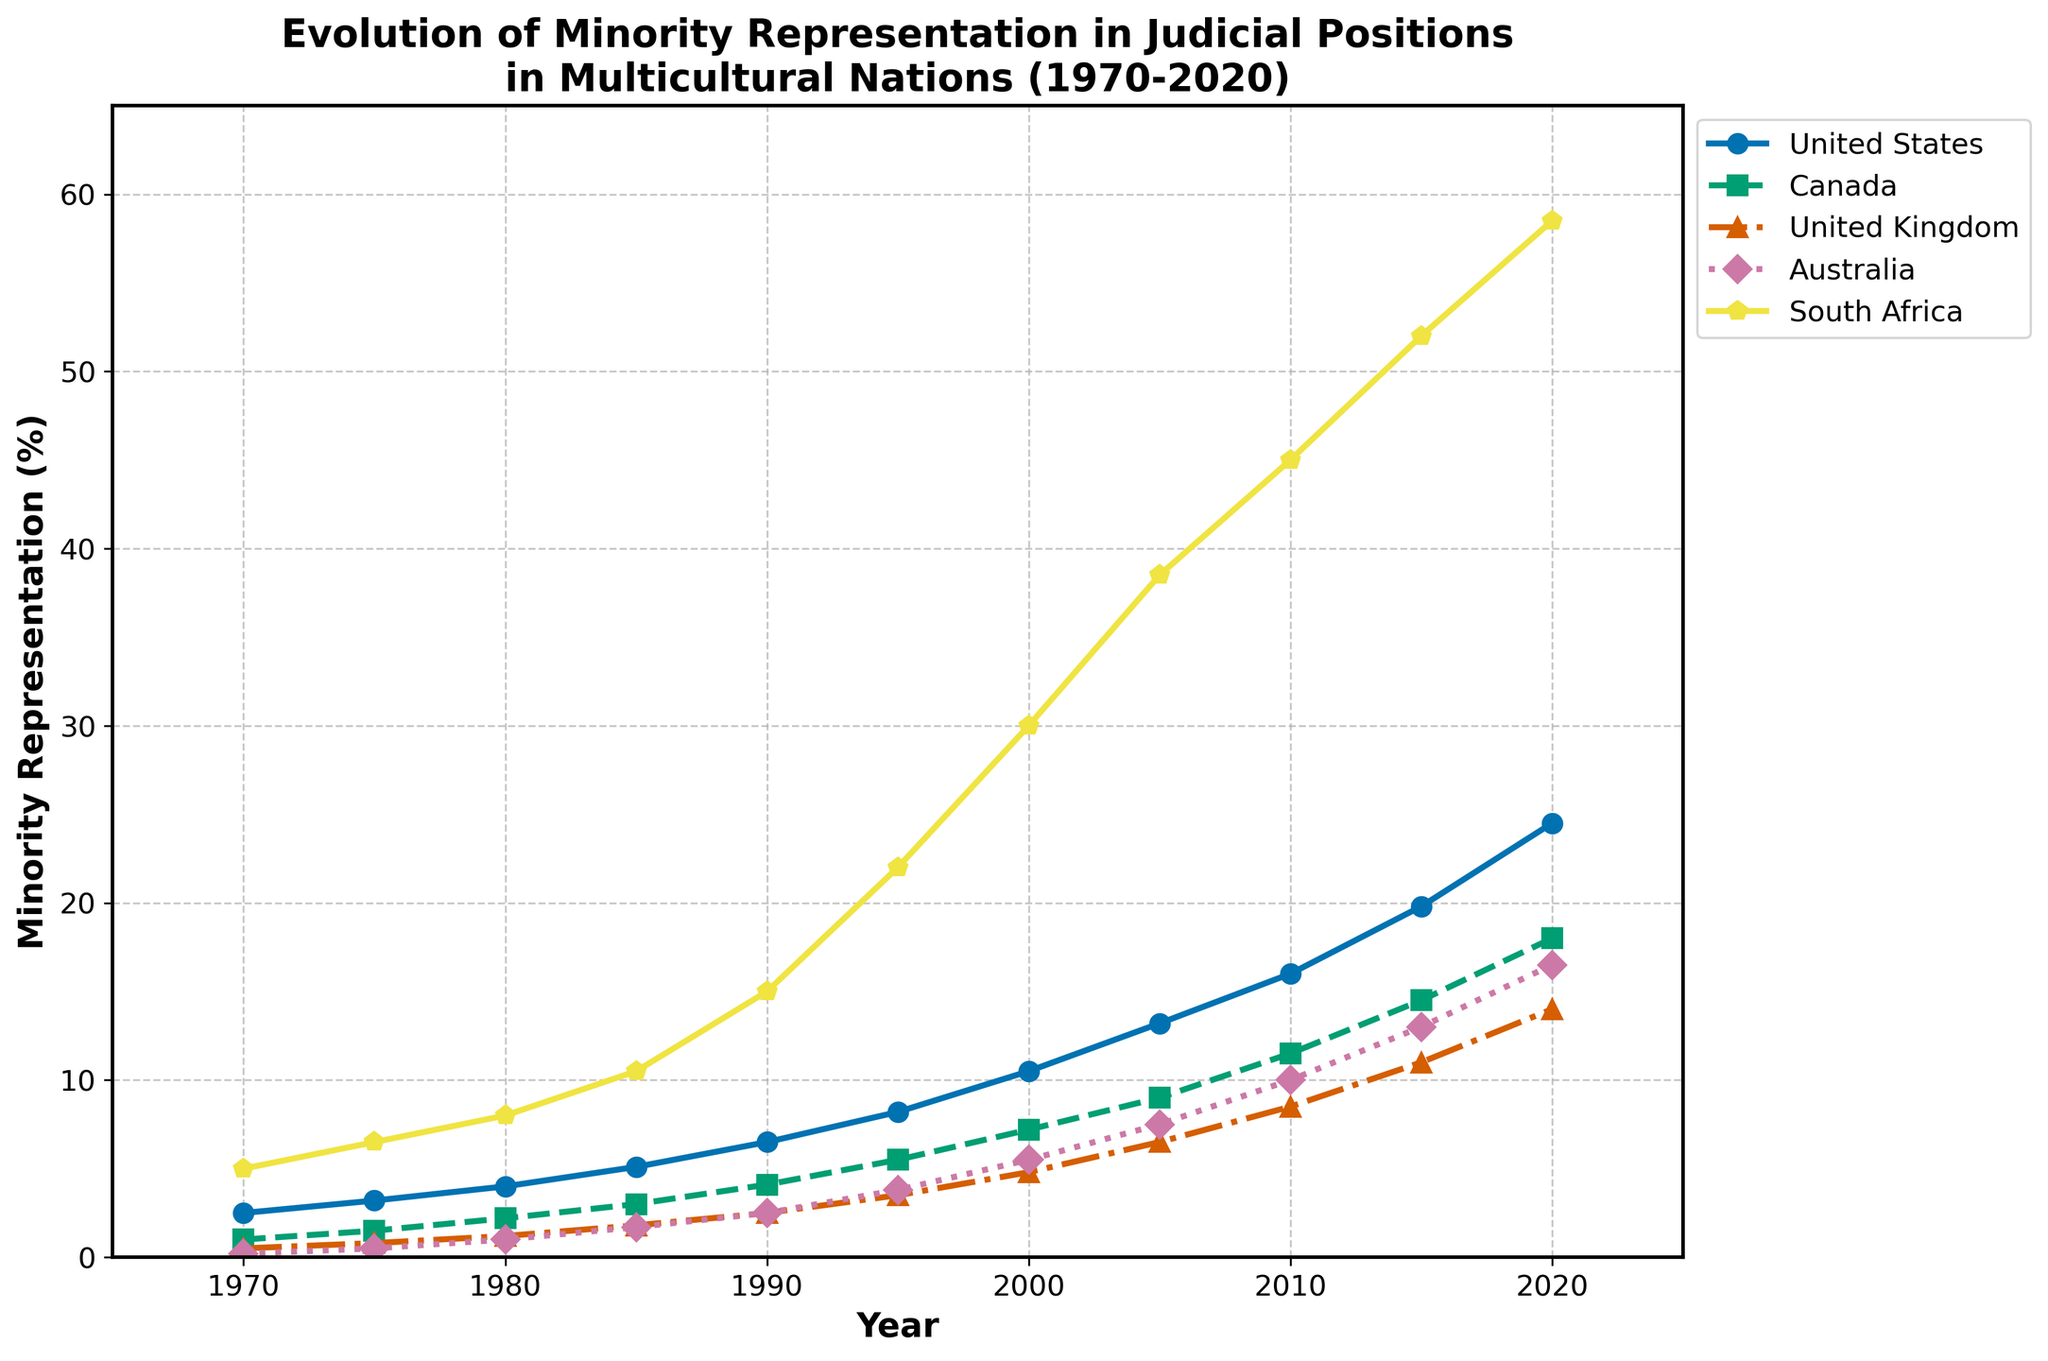what trend do you observe in the representation of minorities in the judicial positions? To answer this question, observe the overall direction of each line in the plot. Each line consistently slopes upwards from left to right.
Answer: The representation of minorities is increasing Which country had the highest percentage increase in minority representation from 1970 to 2020? Look at the endpoints of each line for 1970 and 2020 and find the difference. The increase in South Africa is from 5.0% to 58.5%, which is a 53.5% rise.
Answer: South Africa Which countries had a minority representation percentage under 10% in 2000? Refer to the 2000 data point and observe the y-values for each country. Refer to the United Kingdom (4.8%) and Australia (5.5%) lines.
Answer: United Kingdom, Australia What was the approximate overall trend in the United States' minority representation from 1970 to 2020? Observe the slope of the United States line at the beginning and end. It starts at 2.5% in 1970 and ends at 24.5% in 2020, indicating a consistently increasing trend. Referring to the first subplot from 1970 to 2020 it increases.
Answer: Consistently increasing Compare the minority representation trend between the United States and Canada. What is notable? Examine both lines over the 50-year span and observe the slopes. Both countries show an increasing trend, but the United States has generally higher values than Canada. By looking at the difference between both lines it can be concluded that it is increasing in both places.
Answer: Both increase, US higher In which decade did the minority representation in the United Kingdom exceed that of Australia? Follow the lines for both countries and identify where the UK's line crosses above Australia's line. This crossover occurs between the 1990 and 2000 points.
Answer: 1990s By how much did South Africa's minority representation increase from 1985 to 1995? Identify the y-values for South Africa at 1985 (10.5%) and 1995 (22.0%) and subtract the former from the latter: 22.0% - 10.5% = 11.5%.
Answer: 11.5% What can you infer about the nature of minority representation growth in judicial positions in these countries over the past 50 years? All countries show a positive trend, indicating policy changes or societal shifts promoting diversity in judicial positions.
Answer: Positive trend, implying increased diversity Which country had the most steady increase in minority representation over the 50 years? Look for the line with a consistently smooth slope. Canada's representation steadily increases without much fluctuation.
Answer: Canada 